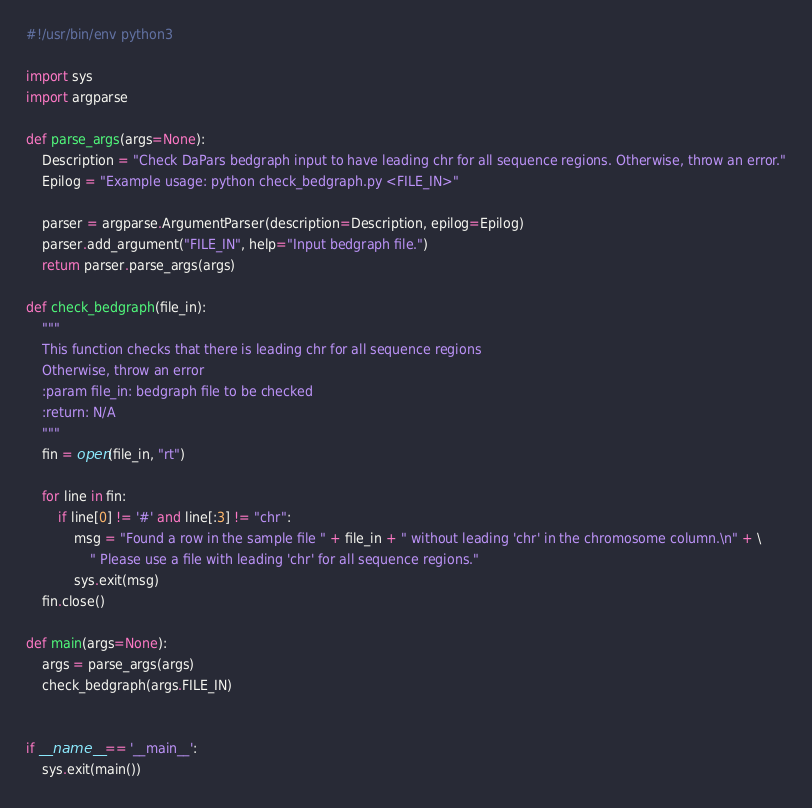<code> <loc_0><loc_0><loc_500><loc_500><_Python_>#!/usr/bin/env python3

import sys
import argparse

def parse_args(args=None):
	Description = "Check DaPars bedgraph input to have leading chr for all sequence regions. Otherwise, throw an error."
	Epilog = "Example usage: python check_bedgraph.py <FILE_IN>"

	parser = argparse.ArgumentParser(description=Description, epilog=Epilog)
	parser.add_argument("FILE_IN", help="Input bedgraph file.")
	return parser.parse_args(args)

def check_bedgraph(file_in):
	"""
	This function checks that there is leading chr for all sequence regions
	Otherwise, throw an error
	:param file_in: bedgraph file to be checked
	:return: N/A
	"""
	fin = open(file_in, "rt")

	for line in fin:
		if line[0] != '#' and line[:3] != "chr":
			msg = "Found a row in the sample file " + file_in + " without leading 'chr' in the chromosome column.\n" + \
				" Please use a file with leading 'chr' for all sequence regions."
			sys.exit(msg)
	fin.close()

def main(args=None):
	args = parse_args(args)
	check_bedgraph(args.FILE_IN)


if __name__ == '__main__':
	sys.exit(main())
</code> 